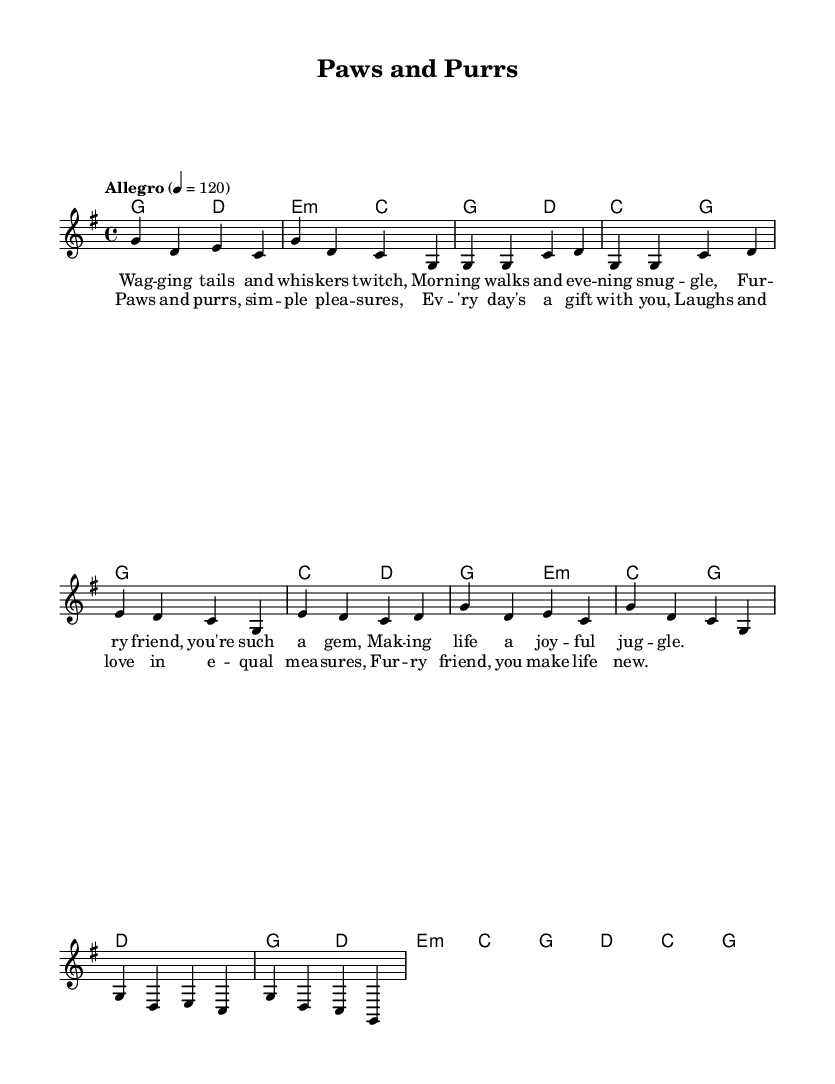What is the key signature of this music? The key signature is G major, which has one sharp (F#). This can be determined by looking at the key signature indicated at the beginning of the music.
Answer: G major What is the time signature of this piece? The time signature is 4/4, indicated at the start of the piece. This means there are four beats in each measure, and the quarter note receives one beat.
Answer: 4/4 What is the tempo marking for the music? The tempo marking is "Allegro," which typically indicates a fast pace. It is specified at the beginning of the sheet music along with the metronome marking of 120 beats per minute.
Answer: Allegro How many measures are in the chorus section? The chorus section consists of four measures, as can be counted directly in the sheet music under the chorus music and lyrics.
Answer: 4 In which section of the song does the following lyric appear: "Fur - ry friend, you're such a gem"? These lyrics appear in the verse section, which follows the specific format of verses found in folk music, creating a narrative about daily life with a furry companion.
Answer: Verse What is the relationship between the melody and harmony in this piece? The melody and harmony are closely related as the harmony supports the melody throughout, with each chord typically accompanying the corresponding notes of the melody, enhancing the folk feel. This can be assessed by matching the melody notes with their respective harmonies.
Answer: Supportive What thematic element is celebrated in this folk tune? The thematic element celebrated in this folk tune is the joy and simplicity of life with a furry companion, focusing on the daily pleasures, as expressed in both the lyrics and the lively tempo.
Answer: Companionship 